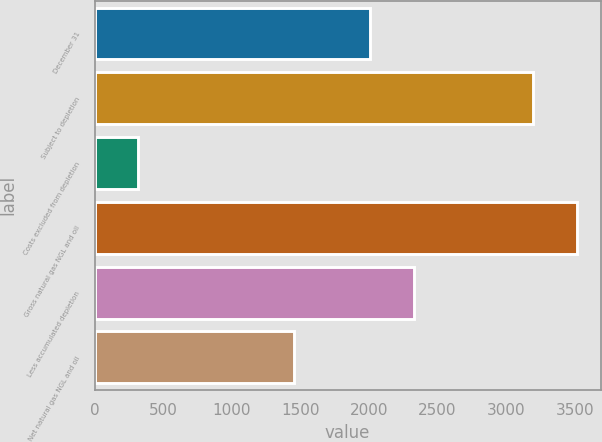Convert chart to OTSL. <chart><loc_0><loc_0><loc_500><loc_500><bar_chart><fcel>December 31<fcel>Subject to depletion<fcel>Costs excluded from depletion<fcel>Gross natural gas NGL and oil<fcel>Less accumulated depletion<fcel>Net natural gas NGL and oil<nl><fcel>2009<fcel>3194<fcel>317<fcel>3513.4<fcel>2328.4<fcel>1450<nl></chart> 